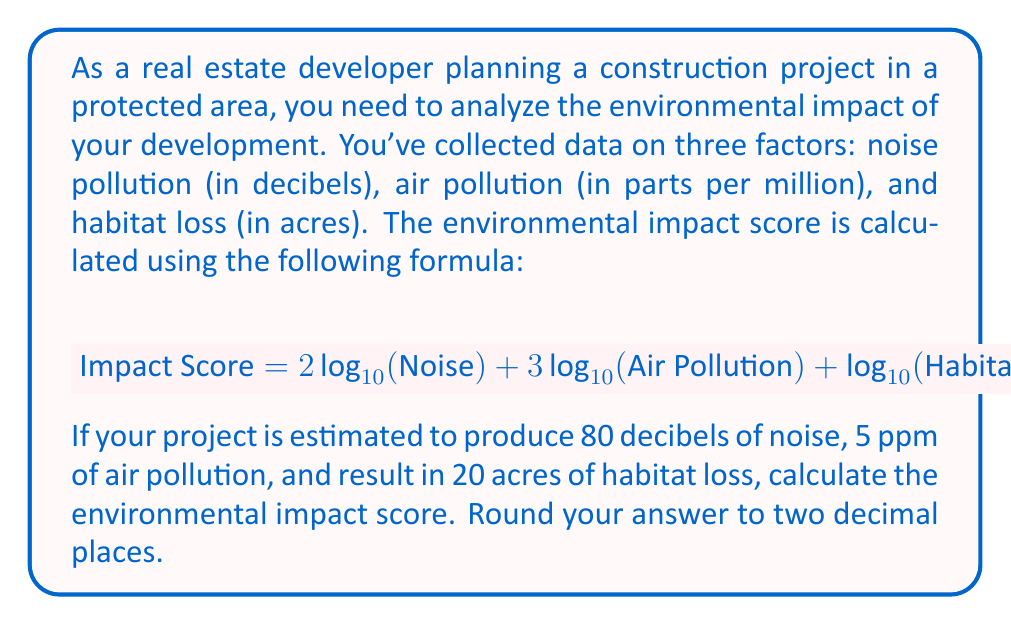Provide a solution to this math problem. To solve this problem, we'll follow these steps:

1. Identify the given values:
   - Noise: 80 decibels
   - Air Pollution: 5 ppm
   - Habitat Loss: 20 acres

2. Apply the formula:
   $$ \text{Impact Score} = 2\log_{10}(\text{Noise}) + 3\log_{10}(\text{Air Pollution}) + \log_{10}(\text{Habitat Loss}) $$

3. Substitute the values:
   $$ \text{Impact Score} = 2\log_{10}(80) + 3\log_{10}(5) + \log_{10}(20) $$

4. Calculate each logarithm:
   - $\log_{10}(80) = 1.9031$
   - $\log_{10}(5) = 0.6990$
   - $\log_{10}(20) = 1.3010$

5. Multiply and sum the terms:
   $$ \text{Impact Score} = 2(1.9031) + 3(0.6990) + 1.3010 $$
   $$ = 3.8062 + 2.0970 + 1.3010 $$
   $$ = 7.2042 $$

6. Round to two decimal places:
   $$ \text{Impact Score} ≈ 7.20 $$
Answer: The environmental impact score is approximately 7.20. 